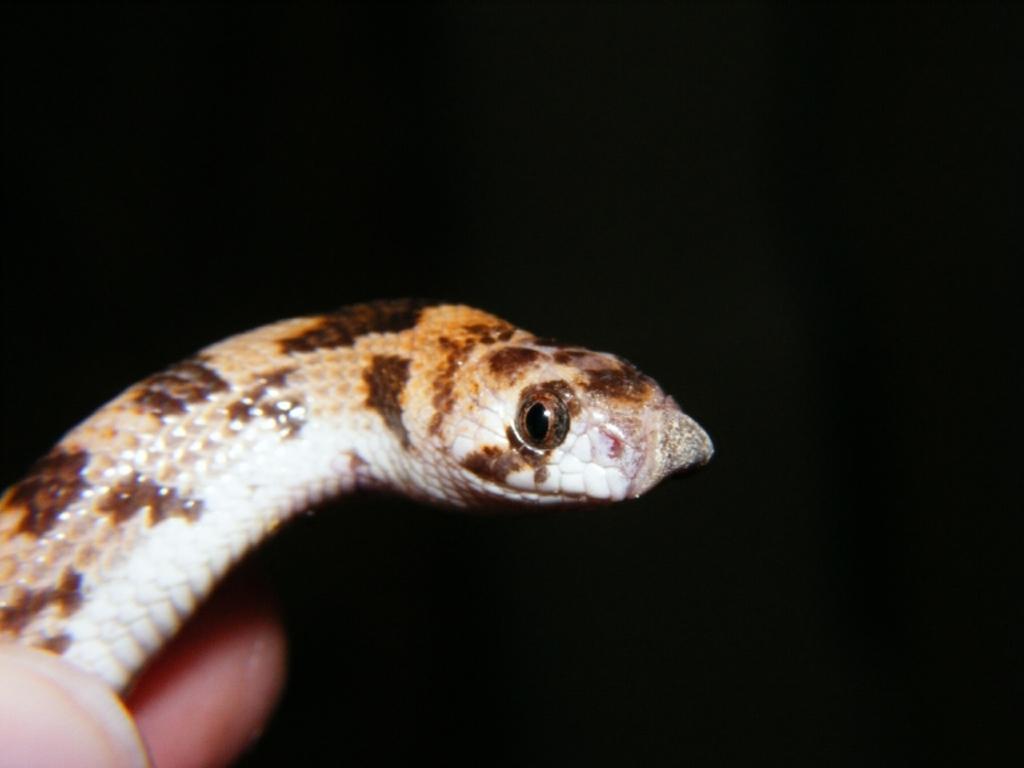Could you give a brief overview of what you see in this image? There is a snake presenting in the black background. 